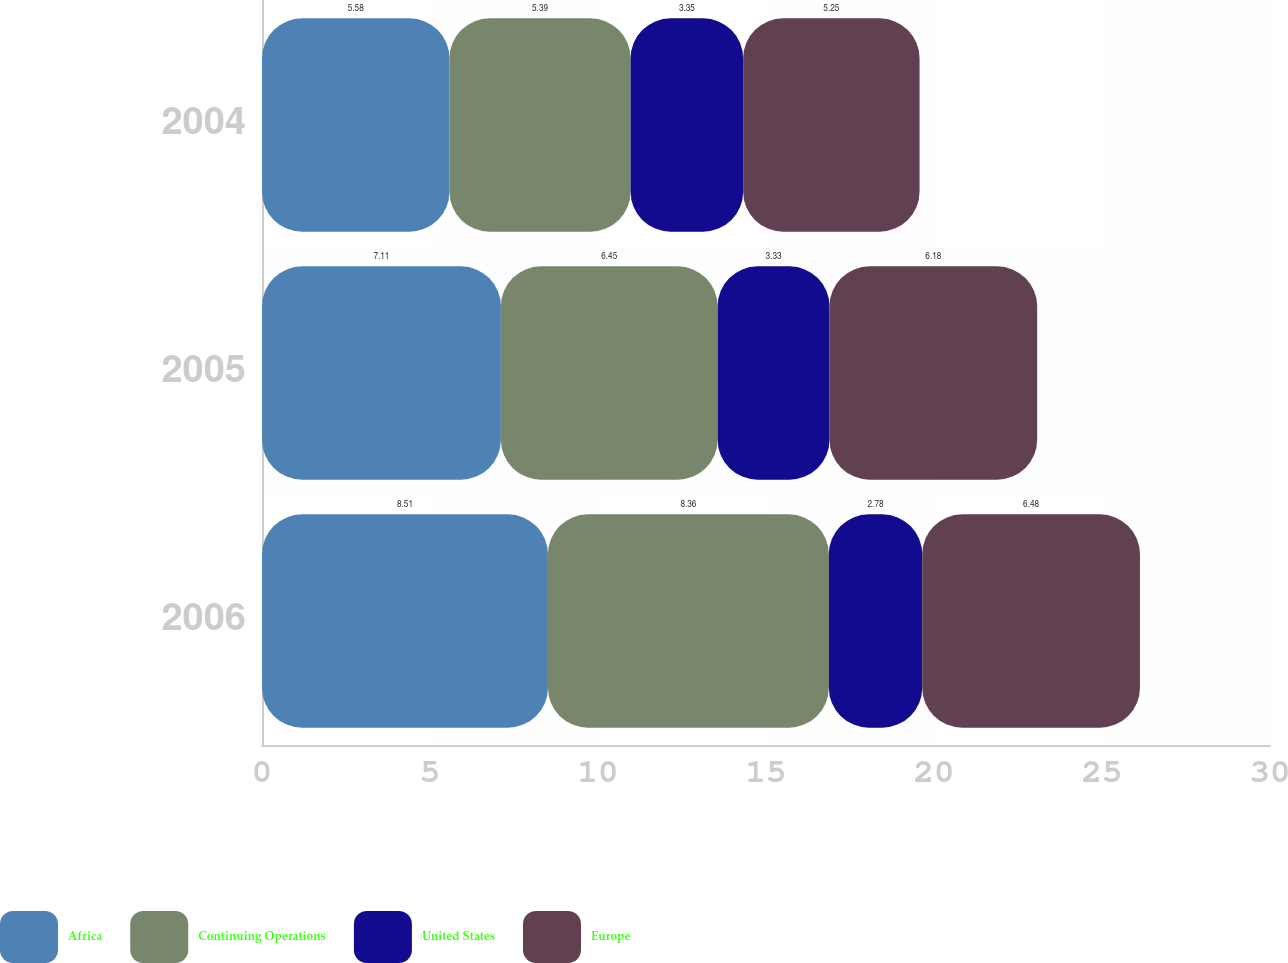<chart> <loc_0><loc_0><loc_500><loc_500><stacked_bar_chart><ecel><fcel>2006<fcel>2005<fcel>2004<nl><fcel>Africa<fcel>8.51<fcel>7.11<fcel>5.58<nl><fcel>Continuing Operations<fcel>8.36<fcel>6.45<fcel>5.39<nl><fcel>United States<fcel>2.78<fcel>3.33<fcel>3.35<nl><fcel>Europe<fcel>6.48<fcel>6.18<fcel>5.25<nl></chart> 